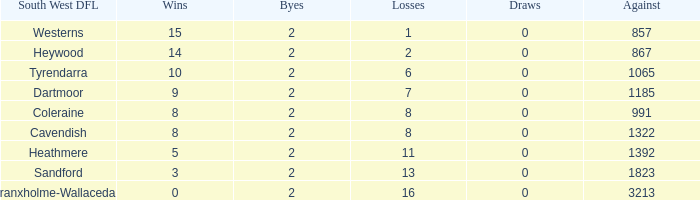What is the number of draws in the south west dfl of tyrendarra having less than 10 victories? None. 